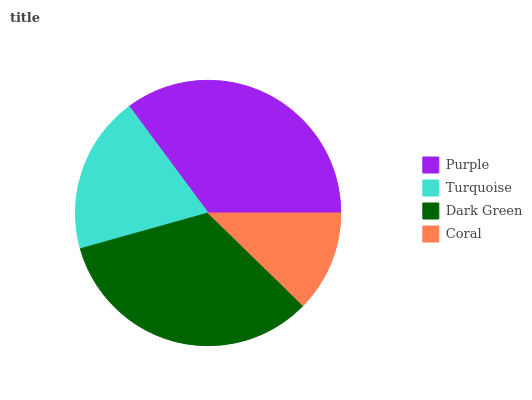Is Coral the minimum?
Answer yes or no. Yes. Is Purple the maximum?
Answer yes or no. Yes. Is Turquoise the minimum?
Answer yes or no. No. Is Turquoise the maximum?
Answer yes or no. No. Is Purple greater than Turquoise?
Answer yes or no. Yes. Is Turquoise less than Purple?
Answer yes or no. Yes. Is Turquoise greater than Purple?
Answer yes or no. No. Is Purple less than Turquoise?
Answer yes or no. No. Is Dark Green the high median?
Answer yes or no. Yes. Is Turquoise the low median?
Answer yes or no. Yes. Is Turquoise the high median?
Answer yes or no. No. Is Dark Green the low median?
Answer yes or no. No. 